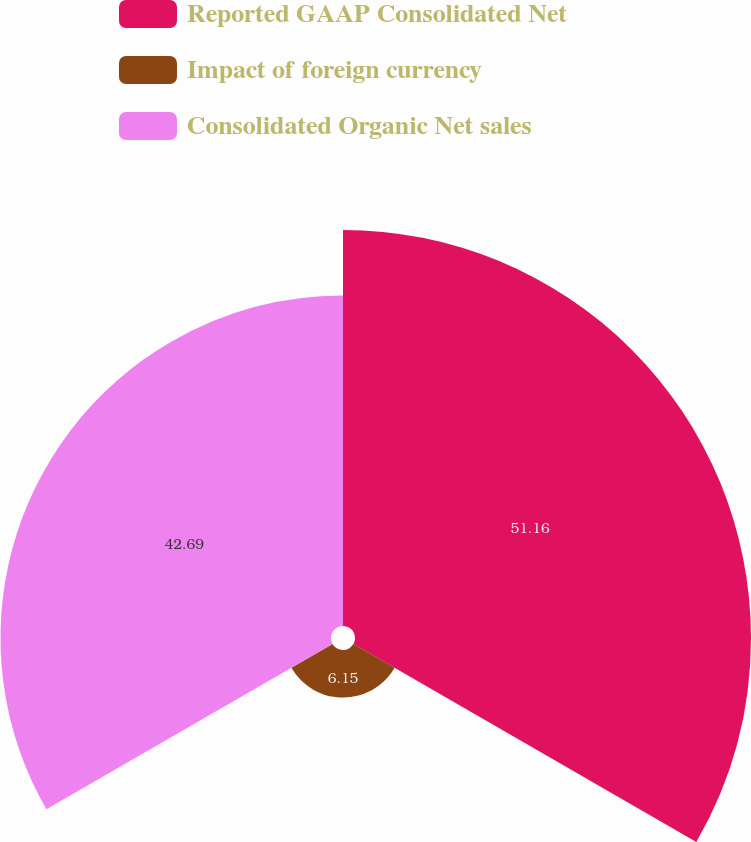<chart> <loc_0><loc_0><loc_500><loc_500><pie_chart><fcel>Reported GAAP Consolidated Net<fcel>Impact of foreign currency<fcel>Consolidated Organic Net sales<nl><fcel>51.15%<fcel>6.15%<fcel>42.69%<nl></chart> 